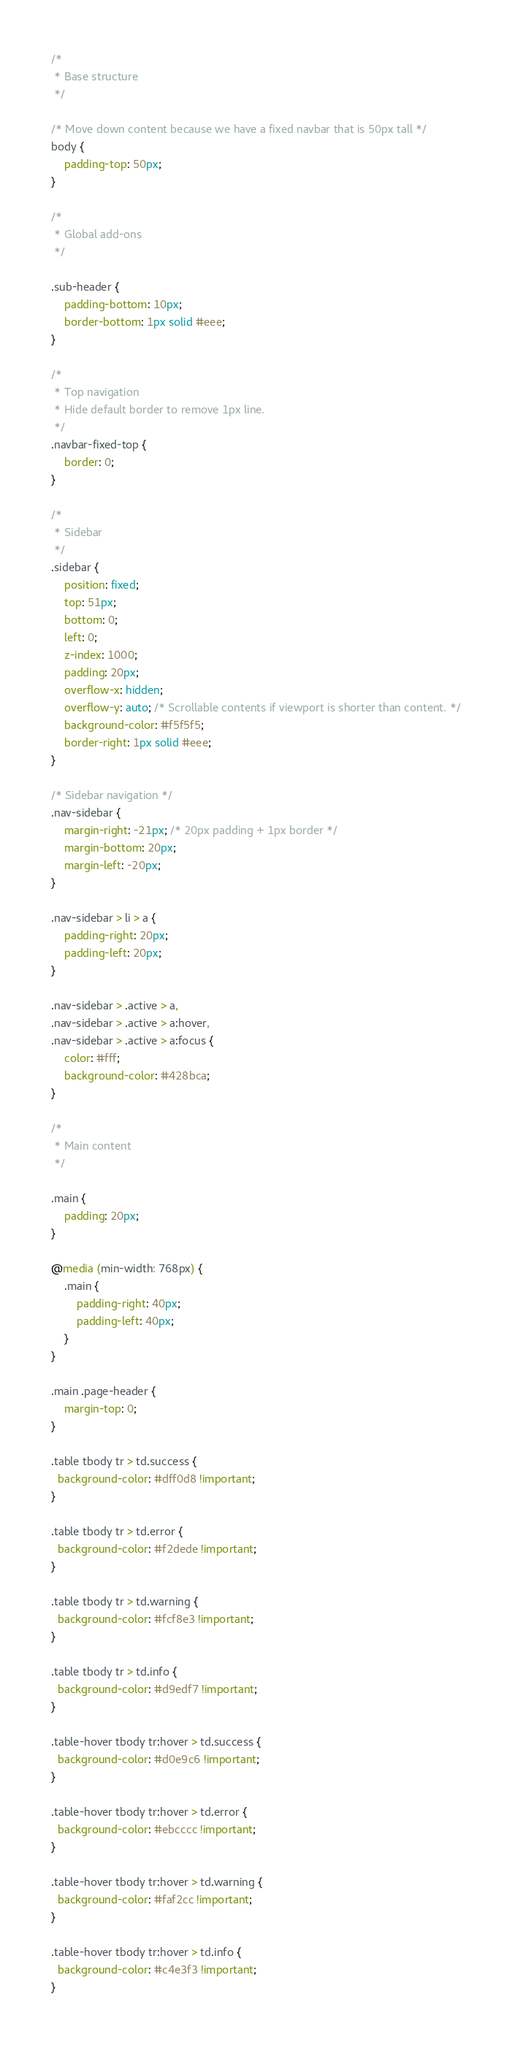<code> <loc_0><loc_0><loc_500><loc_500><_CSS_>/*
 * Base structure
 */

/* Move down content because we have a fixed navbar that is 50px tall */
body {
    padding-top: 50px;
}

/*
 * Global add-ons
 */

.sub-header {
    padding-bottom: 10px;
    border-bottom: 1px solid #eee;
}

/*
 * Top navigation
 * Hide default border to remove 1px line.
 */
.navbar-fixed-top {
    border: 0;
}

/*
 * Sidebar
 */
.sidebar {
    position: fixed;
    top: 51px;
    bottom: 0;
    left: 0;
    z-index: 1000;
    padding: 20px;
    overflow-x: hidden;
    overflow-y: auto; /* Scrollable contents if viewport is shorter than content. */
    background-color: #f5f5f5;
    border-right: 1px solid #eee;
}

/* Sidebar navigation */
.nav-sidebar {
    margin-right: -21px; /* 20px padding + 1px border */
    margin-bottom: 20px;
    margin-left: -20px;
}

.nav-sidebar > li > a {
    padding-right: 20px;
    padding-left: 20px;
}

.nav-sidebar > .active > a,
.nav-sidebar > .active > a:hover,
.nav-sidebar > .active > a:focus {
    color: #fff;
    background-color: #428bca;
}

/*
 * Main content
 */

.main {
    padding: 20px;
}

@media (min-width: 768px) {
    .main {
        padding-right: 40px;
        padding-left: 40px;
    }
}

.main .page-header {
    margin-top: 0;
}

.table tbody tr > td.success {
  background-color: #dff0d8 !important;
}

.table tbody tr > td.error {
  background-color: #f2dede !important;
}

.table tbody tr > td.warning {
  background-color: #fcf8e3 !important;
}

.table tbody tr > td.info {
  background-color: #d9edf7 !important;
}

.table-hover tbody tr:hover > td.success {
  background-color: #d0e9c6 !important;
}

.table-hover tbody tr:hover > td.error {
  background-color: #ebcccc !important;
}

.table-hover tbody tr:hover > td.warning {
  background-color: #faf2cc !important;
}

.table-hover tbody tr:hover > td.info {
  background-color: #c4e3f3 !important;
}</code> 